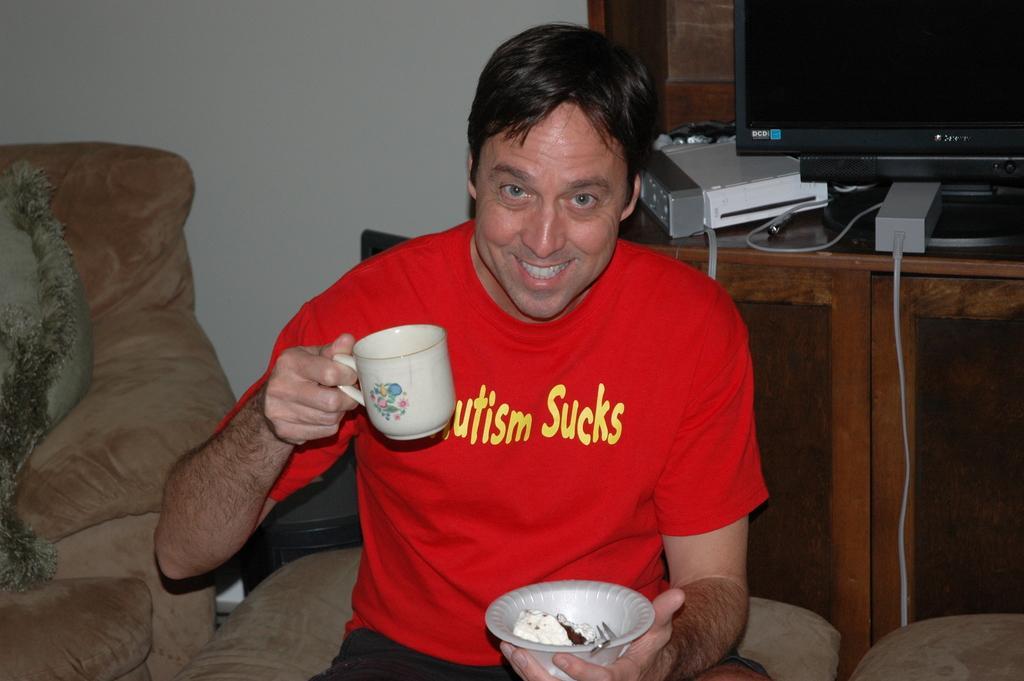Please provide a concise description of this image. This is the picture of a man in red t shirt holding a cup and a bowl. The man is sitting on a chair. Behind the man there is a table on the table there are television and some machines. 